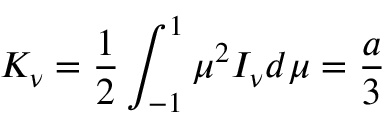<formula> <loc_0><loc_0><loc_500><loc_500>K _ { \nu } = { \frac { 1 } { 2 } } \int _ { - 1 } ^ { 1 } \mu ^ { 2 } I _ { \nu } d \mu = { \frac { a } { 3 } }</formula> 